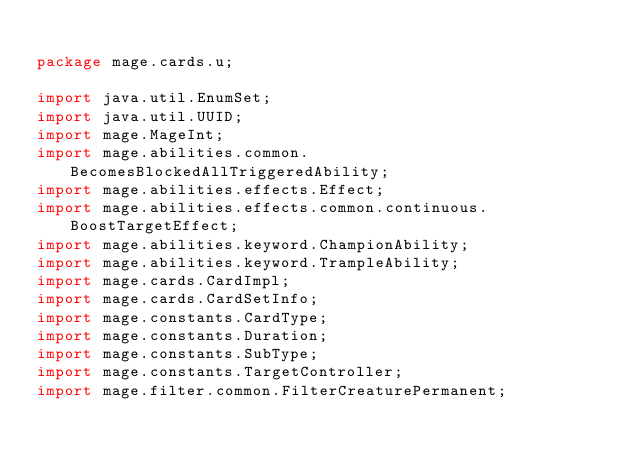Convert code to text. <code><loc_0><loc_0><loc_500><loc_500><_Java_>
package mage.cards.u;

import java.util.EnumSet;
import java.util.UUID;
import mage.MageInt;
import mage.abilities.common.BecomesBlockedAllTriggeredAbility;
import mage.abilities.effects.Effect;
import mage.abilities.effects.common.continuous.BoostTargetEffect;
import mage.abilities.keyword.ChampionAbility;
import mage.abilities.keyword.TrampleAbility;
import mage.cards.CardImpl;
import mage.cards.CardSetInfo;
import mage.constants.CardType;
import mage.constants.Duration;
import mage.constants.SubType;
import mage.constants.TargetController;
import mage.filter.common.FilterCreaturePermanent;</code> 